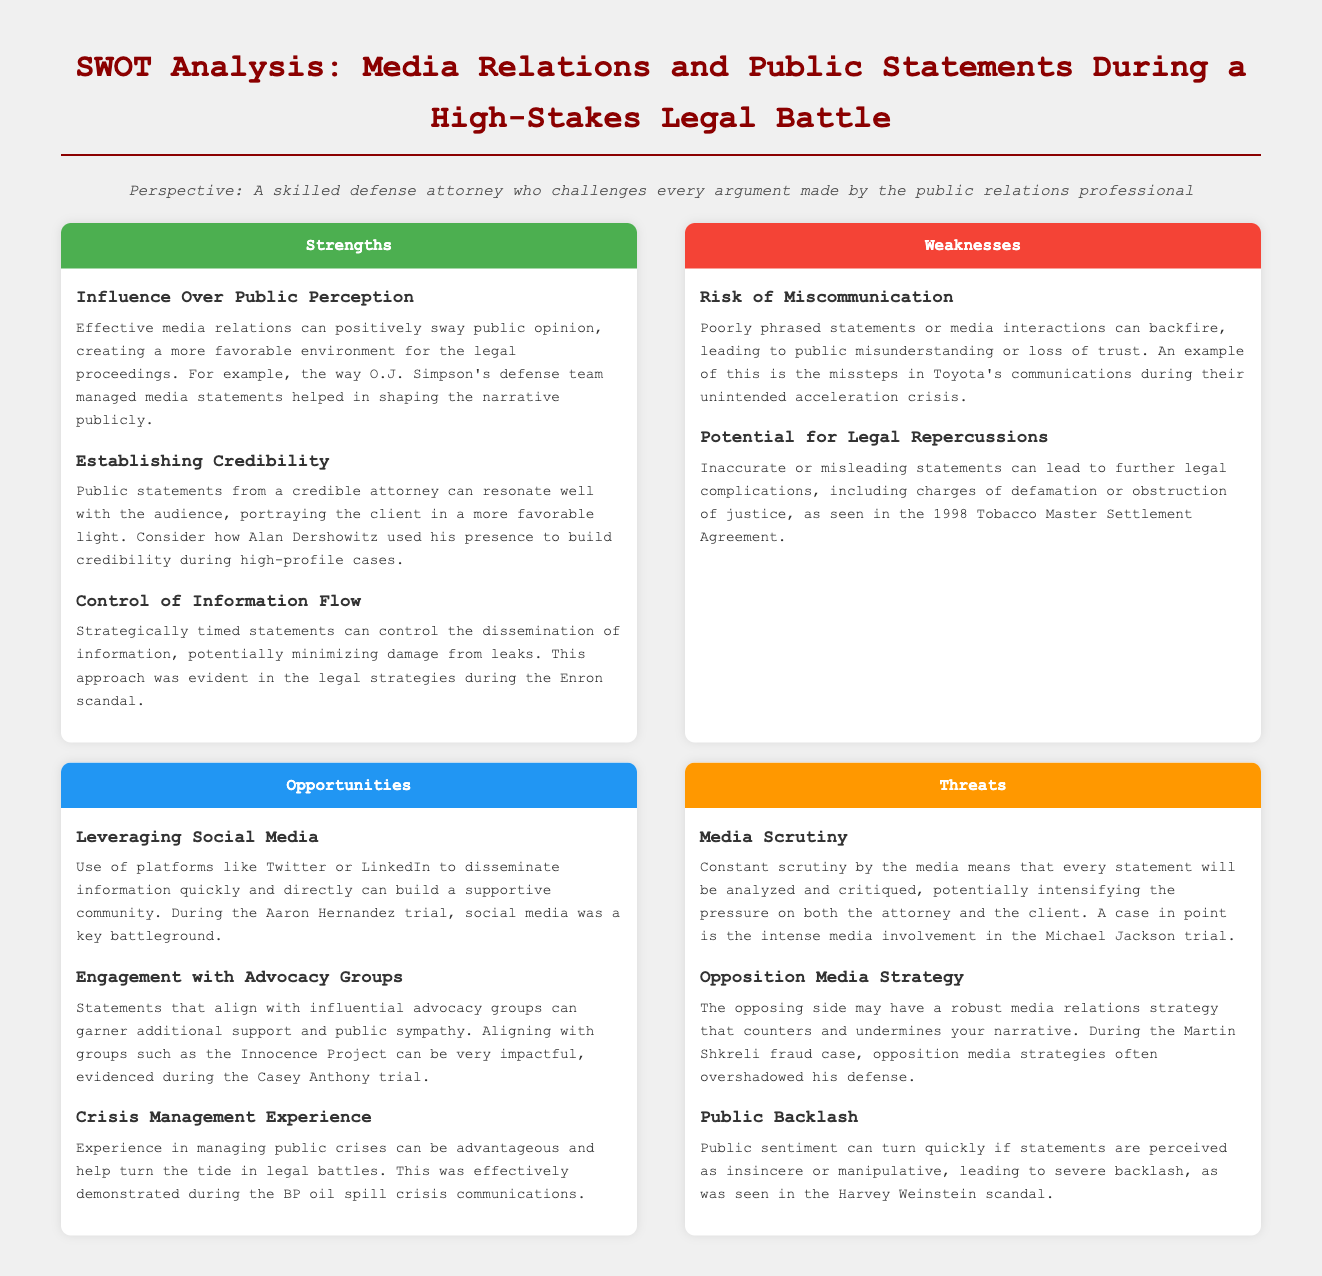What is one advantage of effective media relations? The document states that effective media relations can positively sway public opinion, creating a more favorable environment for the legal proceedings.
Answer: Influence Over Public Perception What is a potential risk of poorly phrased statements? The document highlights that poorly phrased statements or media interactions can lead to public misunderstanding or loss of trust.
Answer: Risk of Miscommunication Which case is mentioned as an example of leveraging social media? The document refers to the Aaron Hernandez trial as a key example of using social media for disseminating information.
Answer: Aaron Hernandez trial What is a threat mentioned regarding media scrutiny? The document states that constant scrutiny by the media means that every statement will be analyzed and critiqued.
Answer: Media Scrutiny Which advocacy group is suggested for alignment to garner support? The document suggests aligning with groups like the Innocence Project for additional support and public sympathy.
Answer: Innocence Project What was one effective demonstration of crisis management? The document mentions the BP oil spill crisis communications as an example of effective crisis management.
Answer: BP oil spill crisis What is described as a potential consequence of insincere statements? The document warns that public sentiment can turn quickly, leading to severe backlash if statements are perceived as manipulative.
Answer: Public Backlash Which legal battle demonstrates the influence of opposition media strategy? The document cites the Martin Shkreli fraud case as one where opposition media strategies overshadowed the defense.
Answer: Martin Shkreli fraud case 